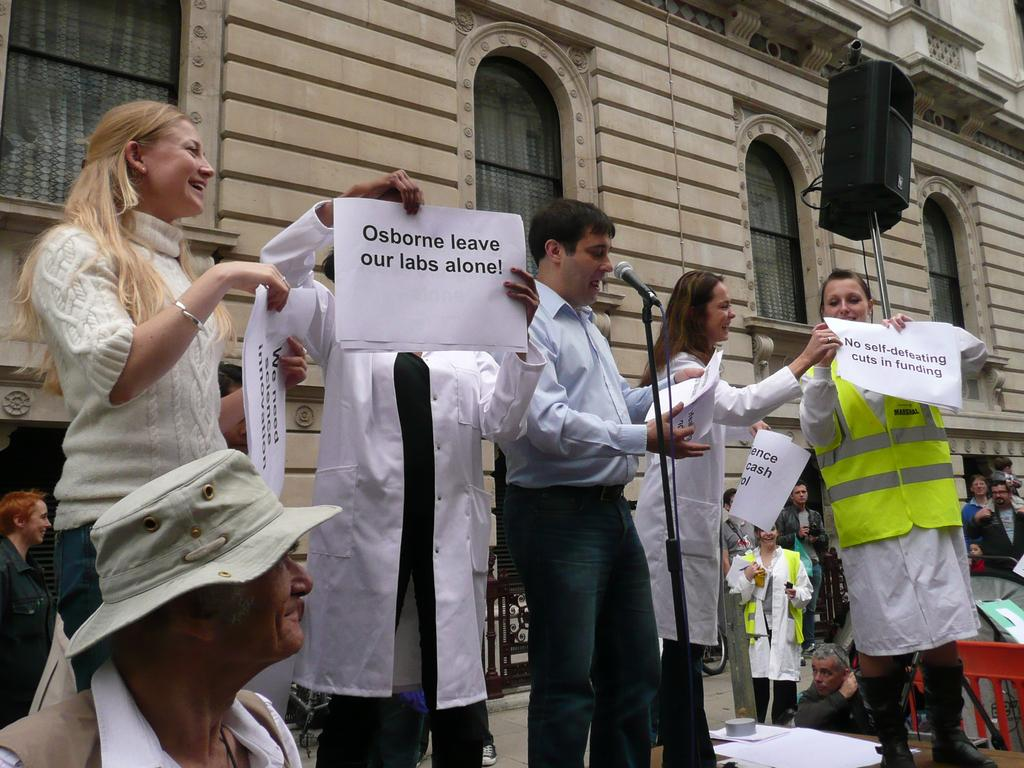How many people are present in the image? There are persons in the image, but the exact number cannot be determined from the provided facts. What object is used for amplifying sound in the image? There is a microphone in the image. What type of items can be seen in the image besides the microphone? There are papers and other objects visible in the image. What can be seen in the background of the image? There is a building, persons, and other objects in the background of the image. What type of toothpaste is being used by the doctor in the image? There is no toothpaste or doctor present in the image. What type of eggnog is being served to the persons in the image? There is no eggnog present in the image. 